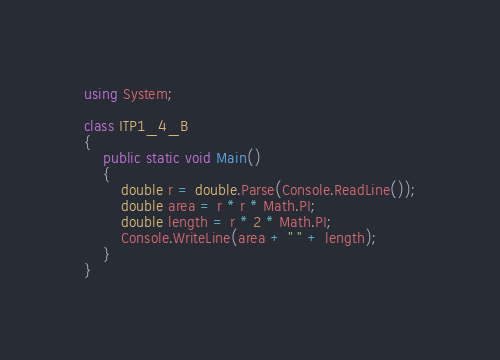<code> <loc_0><loc_0><loc_500><loc_500><_C#_>using System;

class ITP1_4_B
{
    public static void Main()
    {
        double r = double.Parse(Console.ReadLine());
        double area = r * r * Math.PI;
        double length = r * 2 * Math.PI;
        Console.WriteLine(area + " " + length);
    }
}</code> 